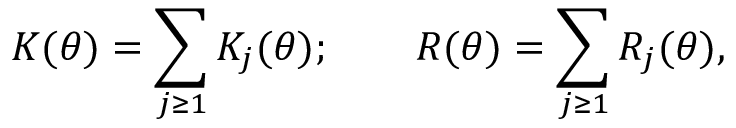Convert formula to latex. <formula><loc_0><loc_0><loc_500><loc_500>K ( \theta ) = \sum _ { j \geq 1 } K _ { j } ( \theta ) ; \quad R ( \theta ) = \sum _ { j \geq 1 } R _ { j } ( \theta ) ,</formula> 